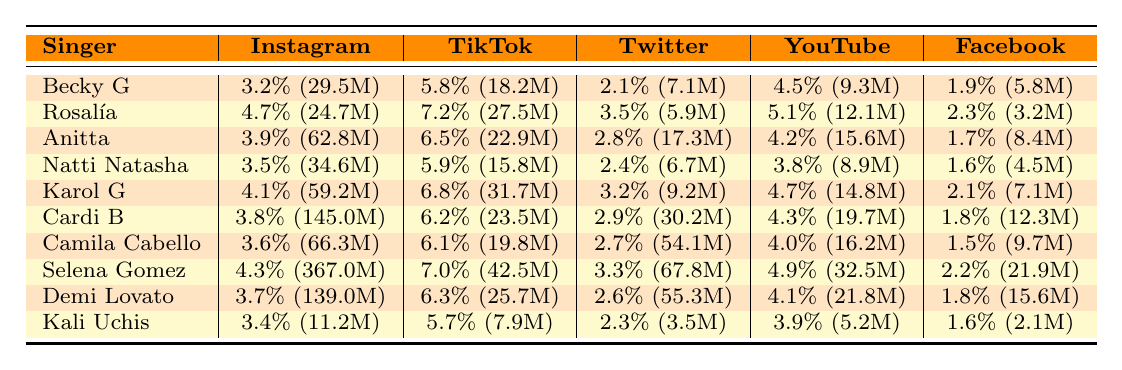What is the highest engagement rate on Instagram among the singers? To find the highest engagement rate on Instagram, we look at the Instagram column of engagement rates. The values are 3.2%, 4.7%, 3.9%, 3.5%, 4.1%, 3.8%, 3.6%, 4.3%, 3.7%, and 3.4%. The maximum value is 4.7%, which belongs to Rosalía.
Answer: 4.7% Which singer has the most followers on Facebook? By checking the Facebook follower counts, the values are 5.8M, 3.2M, 8.4M, 4.5M, 7.1M, 12.3M, 9.7M, 21.9M, 15.6M, and 2.1M. The highest value is 21.9M, attributed to Selena Gomez.
Answer: Selena Gomez What is the average engagement rate for TikTok across all singers? We sum the engagement rates for TikTok: (5.8 + 7.2 + 6.5 + 5.9 + 6.8 + 6.2 + 6.1 + 7.0 + 6.3 + 5.7) = 58.5%. There are 10 singers, so the average is 58.5% / 10 = 5.85%.
Answer: 5.85% Is Cardi B's engagement rate higher on Instagram or Twitter? Looking at the engagement rates, Cardi B has 3.8% on Instagram and 2.9% on Twitter. Since 3.8% is greater than 2.9%, Cardi B's engagement rate is higher on Instagram.
Answer: Yes Which singer has the lowest average posts per week? The average posts per week for the singers are 5, 4, 6, 5, 7, 4, 5, 3, 4, and 6. The lowest number is 3, which corresponds to Selena Gomez.
Answer: Selena Gomez What percentage of the average engagement rate on YouTube does Anitta have compared to Selena Gomez? Anitta's engagement rate on YouTube is 4.2%, and Selena Gomez's is 4.9%. To find the percentage comparison, we calculate (4.2 / 4.9) * 100 = 85.71%.
Answer: 85.71% Which platform has the highest engagement rate by Karol G? Karol G's engagement rates are 4.1% on Instagram, 6.8% on TikTok, 3.2% on Twitter, 4.7% on YouTube, and 2.1% on Facebook. The highest engagement rate is 6.8% on TikTok.
Answer: TikTok Which singer has an engagement rate lower than 4% on both Instagram and Facebook? The engagement rates below 4% on Instagram are 3.2%, 3.5%, 3.8%, 3.6%, 3.7%, and 3.4%, which correspond to Becky G, Natti Natasha, Cardi B, Camila Cabello, Demi Lovato, and Kali Uchis. The Facebook engagement rates to check are all above 1.5%, hence Kelly Uchis with 1.6% engagement rate on Facebook fits.
Answer: Kali Uchis How much higher is the engagement rate on TikTok for Rosalía compared to Anitta? Rosalía's TikTok engagement rate is 7.2% and Anitta's is 6.5%. The difference is 7.2% - 6.5% = 0.7%.
Answer: 0.7% Which singer consistently engages above 3% across all platforms? We check each singer's rates across all platforms. Selena Gomez has all rates: 4.3%, 7.0%, 3.3%, 4.9%, and 2.2%, while others have engagement rates falling below 3% in various platforms. Thus, Selena Gomez is the only singer with consistently above 3% engagement rates.
Answer: Selena Gomez 